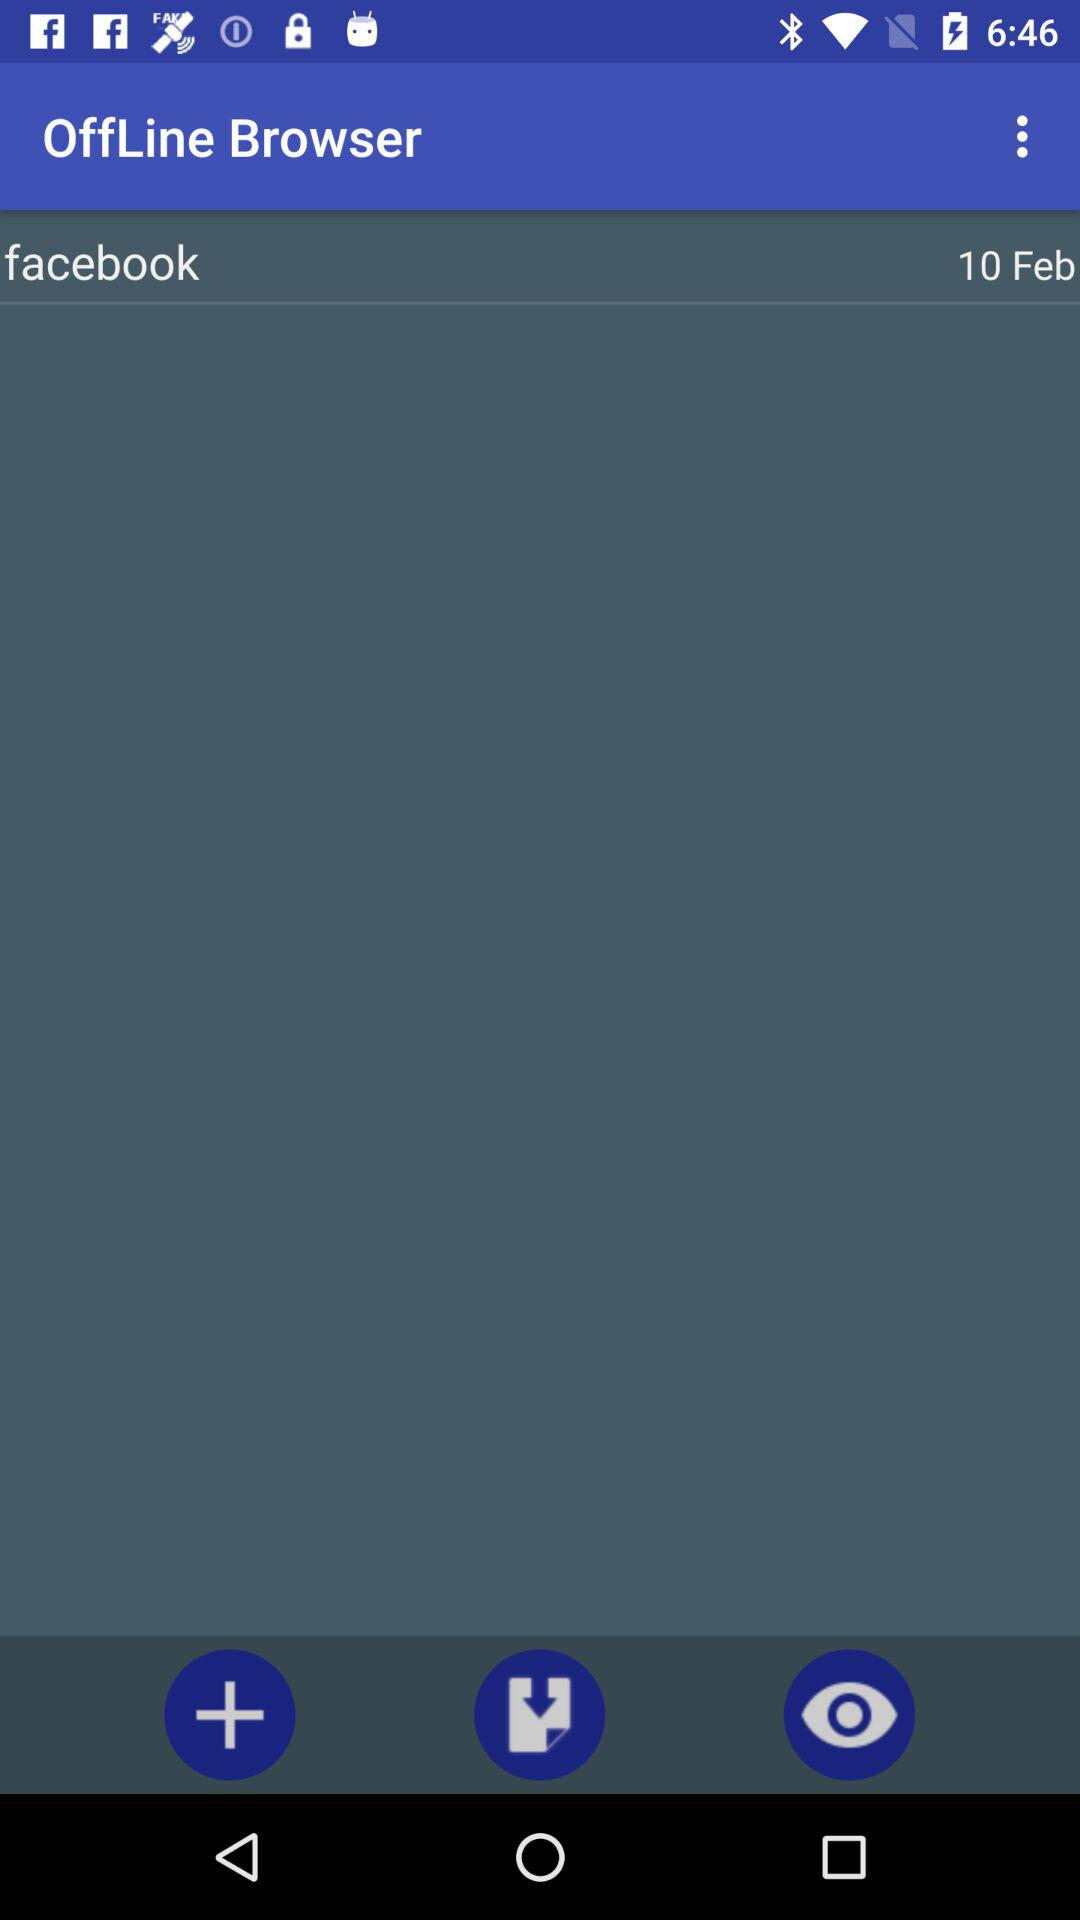What is the mentioned date? The mentioned date is February 10. 